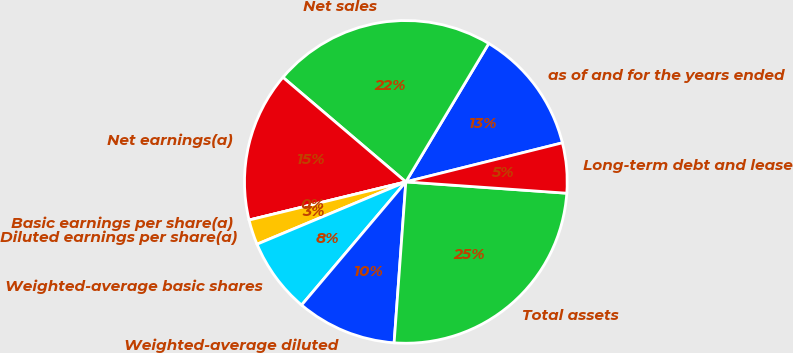Convert chart to OTSL. <chart><loc_0><loc_0><loc_500><loc_500><pie_chart><fcel>as of and for the years ended<fcel>Net sales<fcel>Net earnings(a)<fcel>Basic earnings per share(a)<fcel>Diluted earnings per share(a)<fcel>Weighted-average basic shares<fcel>Weighted-average diluted<fcel>Total assets<fcel>Long-term debt and lease<nl><fcel>12.52%<fcel>22.37%<fcel>15.02%<fcel>0.0%<fcel>2.51%<fcel>7.51%<fcel>10.02%<fcel>25.04%<fcel>5.01%<nl></chart> 